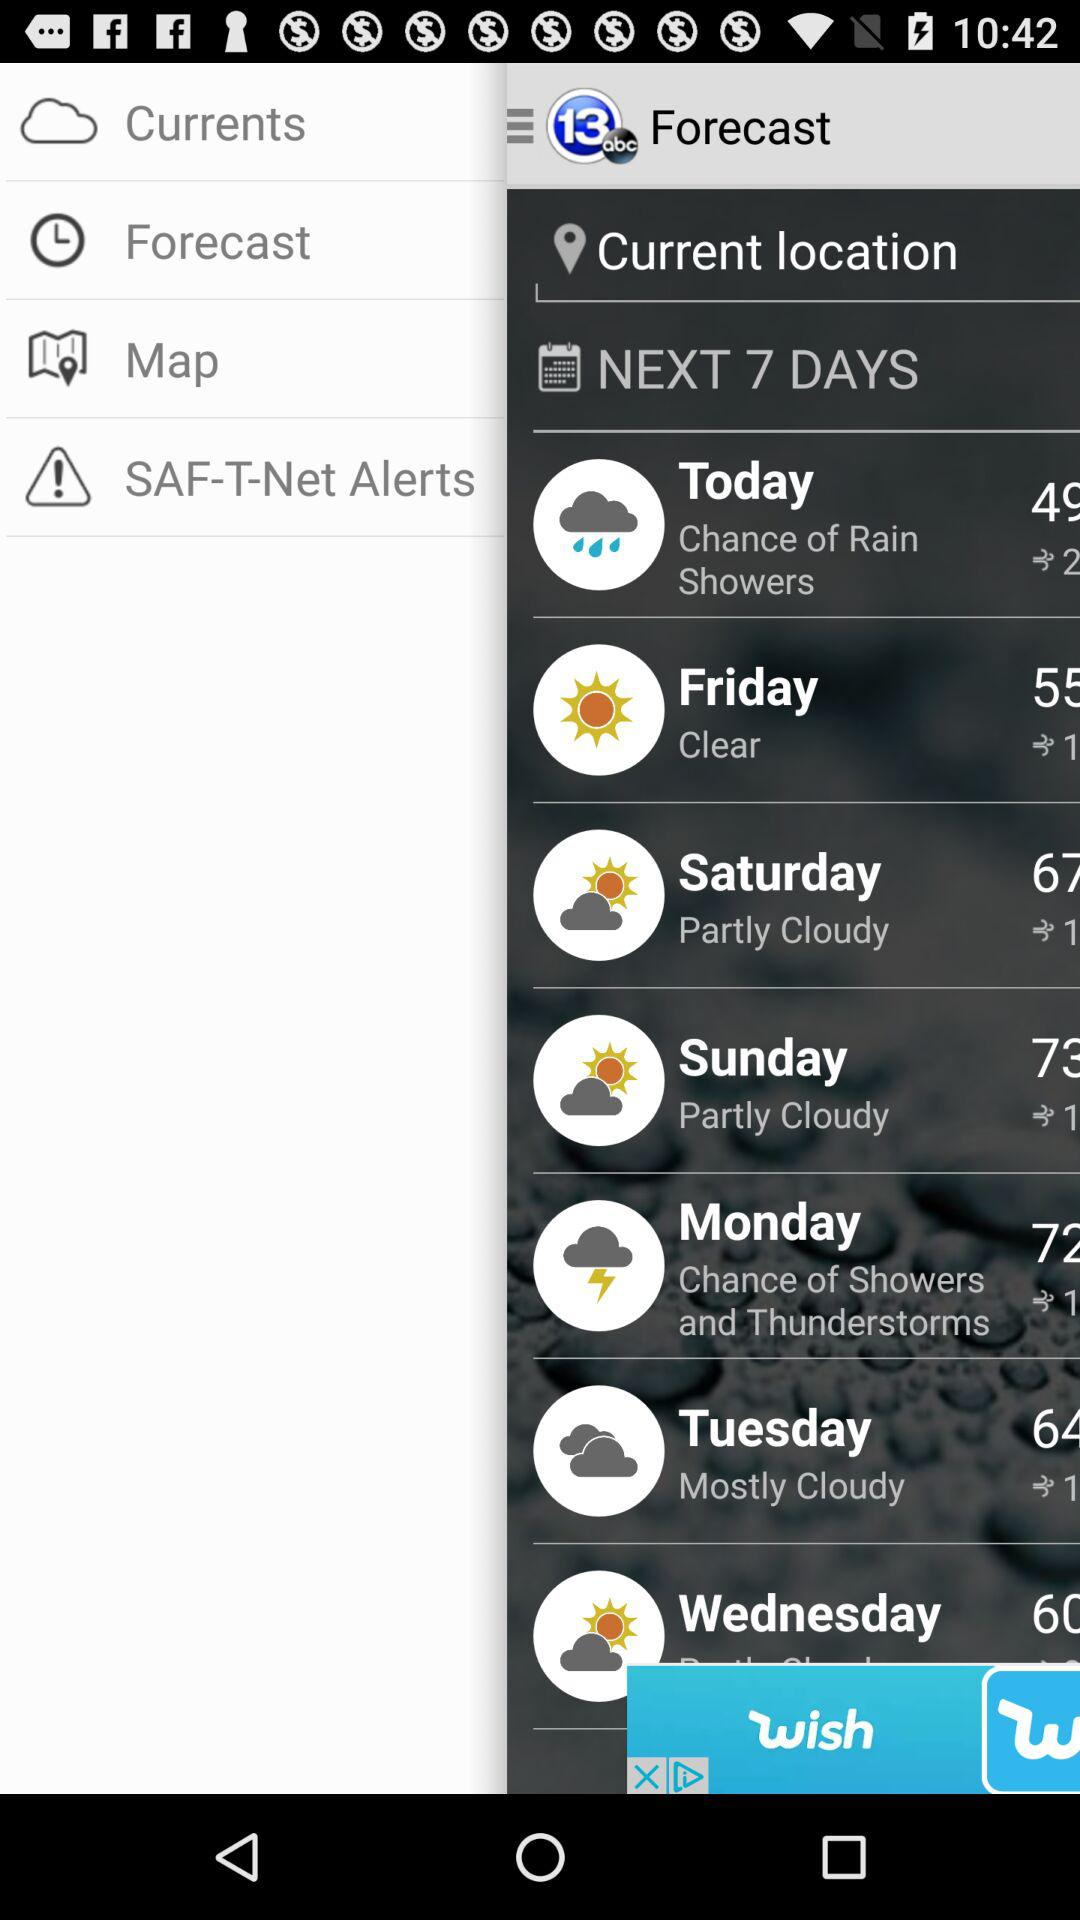What is the weather forecast for Friday? The weather is clear. 